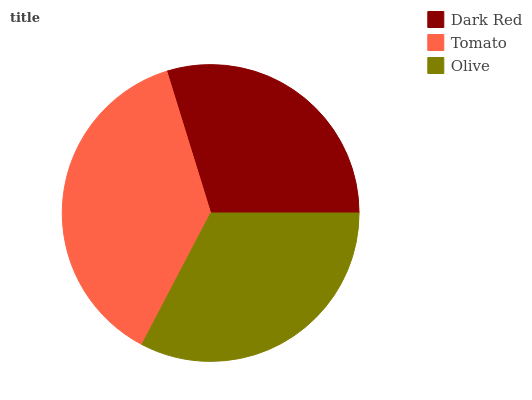Is Dark Red the minimum?
Answer yes or no. Yes. Is Tomato the maximum?
Answer yes or no. Yes. Is Olive the minimum?
Answer yes or no. No. Is Olive the maximum?
Answer yes or no. No. Is Tomato greater than Olive?
Answer yes or no. Yes. Is Olive less than Tomato?
Answer yes or no. Yes. Is Olive greater than Tomato?
Answer yes or no. No. Is Tomato less than Olive?
Answer yes or no. No. Is Olive the high median?
Answer yes or no. Yes. Is Olive the low median?
Answer yes or no. Yes. Is Tomato the high median?
Answer yes or no. No. Is Tomato the low median?
Answer yes or no. No. 